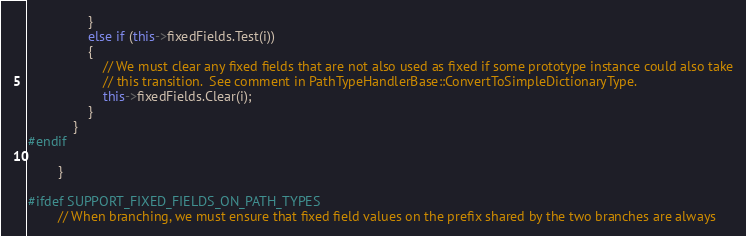Convert code to text. <code><loc_0><loc_0><loc_500><loc_500><_C++_>                }
                else if (this->fixedFields.Test(i))
                {
                    // We must clear any fixed fields that are not also used as fixed if some prototype instance could also take
                    // this transition.  See comment in PathTypeHandlerBase::ConvertToSimpleDictionaryType.
                    this->fixedFields.Clear(i);
                }
            }
#endif

        }

#ifdef SUPPORT_FIXED_FIELDS_ON_PATH_TYPES
        // When branching, we must ensure that fixed field values on the prefix shared by the two branches are always</code> 